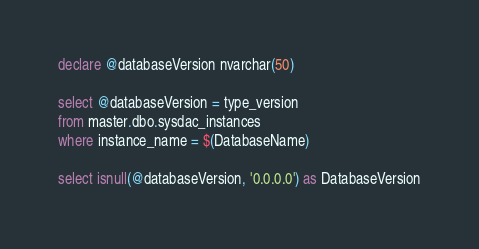<code> <loc_0><loc_0><loc_500><loc_500><_SQL_>declare @databaseVersion nvarchar(50)

select @databaseVersion = type_version
from master.dbo.sysdac_instances
where instance_name = $(DatabaseName)

select isnull(@databaseVersion, '0.0.0.0') as DatabaseVersion</code> 